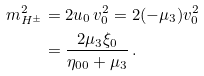<formula> <loc_0><loc_0><loc_500><loc_500>m _ { H ^ { \pm } } ^ { 2 } & = 2 u _ { 0 } \, v _ { 0 } ^ { 2 } = 2 ( - \mu _ { 3 } ) v _ { 0 } ^ { 2 } \\ & = \frac { 2 \mu _ { 3 } \xi _ { 0 } } { \eta _ { 0 0 } + \mu _ { 3 } } \, .</formula> 